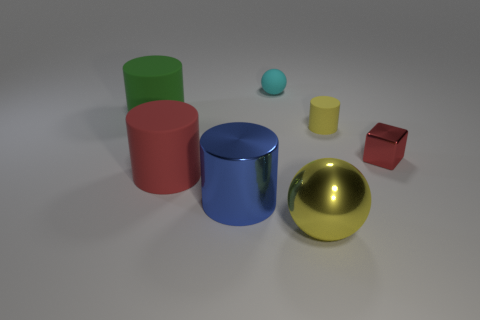Is there any other thing that is the same shape as the red metal thing?
Provide a succinct answer. No. There is a ball in front of the large green cylinder to the left of the small red metallic thing; is there a big green matte cylinder that is on the right side of it?
Provide a succinct answer. No. There is a cylinder that is behind the yellow matte object; is its size the same as the yellow shiny thing?
Make the answer very short. Yes. How many things have the same size as the metal sphere?
Provide a short and direct response. 3. What size is the metallic object that is the same color as the small cylinder?
Ensure brevity in your answer.  Large. Do the cube and the tiny matte cylinder have the same color?
Offer a very short reply. No. The small cyan thing has what shape?
Your answer should be very brief. Sphere. Is there a big thing of the same color as the tiny cylinder?
Make the answer very short. Yes. Is the number of cyan things in front of the tiny yellow matte object greater than the number of yellow balls?
Ensure brevity in your answer.  No. Does the red matte thing have the same shape as the matte object on the left side of the red rubber object?
Provide a succinct answer. Yes. 